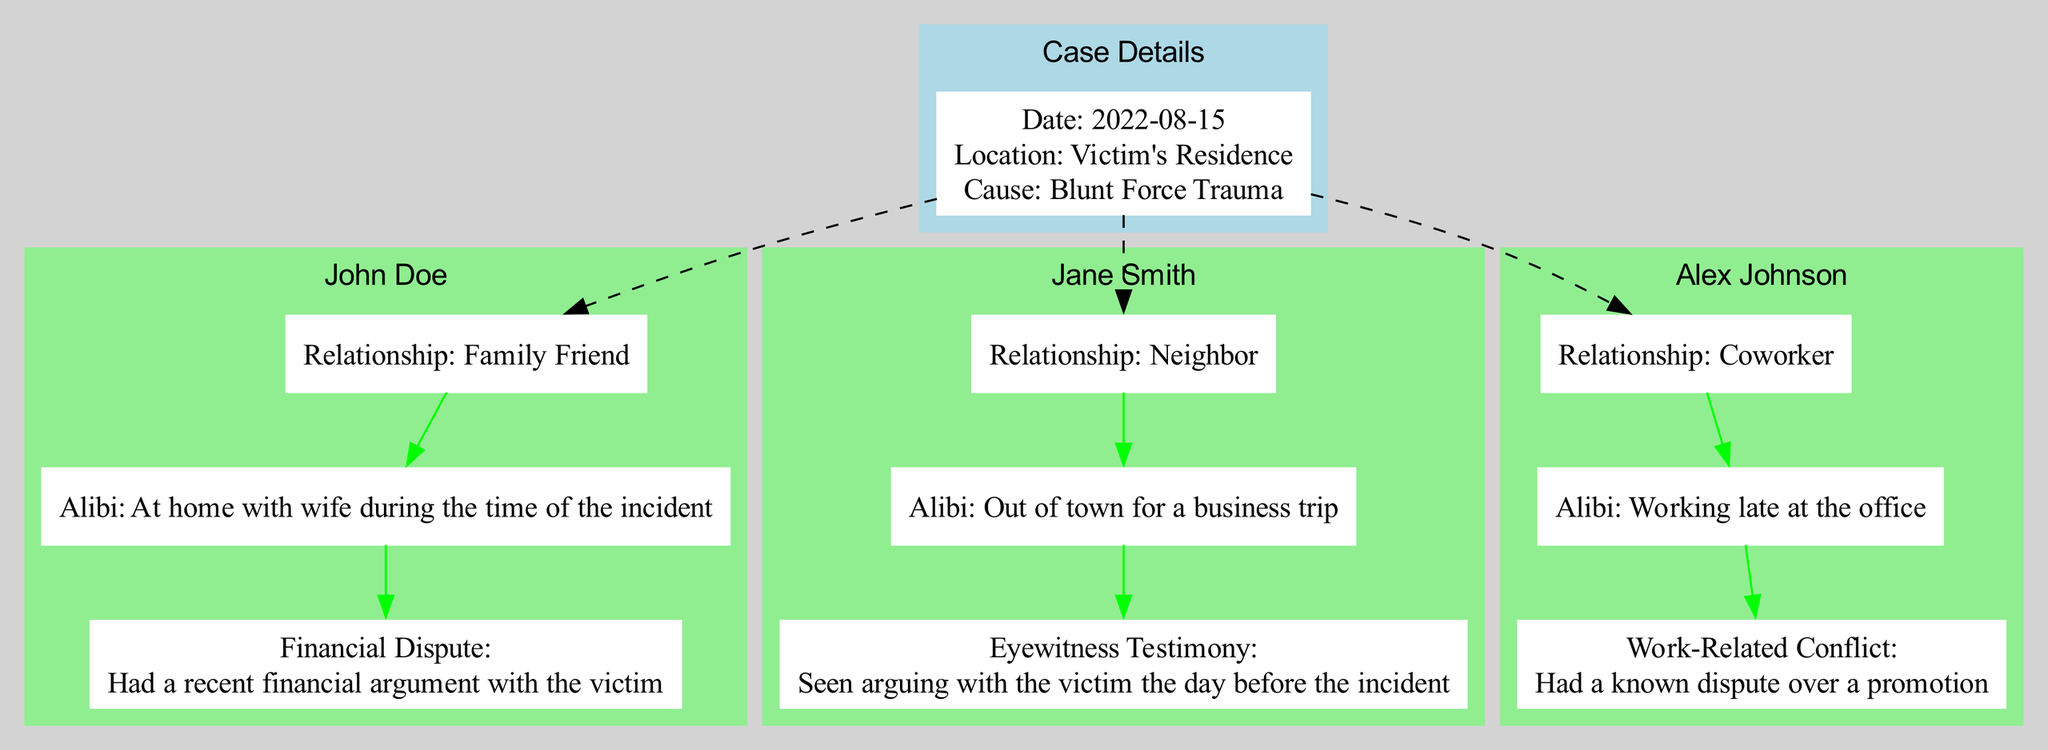What is the name of the first suspect? The diagram lists the potential suspects and shows their names clearly. The first name in the list is John Doe.
Answer: John Doe What was the cause of death? The diagram contains a node detailing the case information, and it specifies the cause of death as blunt force trauma.
Answer: Blunt Force Trauma How many connections does Alex Johnson have to the case? Alex Johnson has one connection listed in the diagram, which is a work-related conflict.
Answer: 1 What was Jane Smith's alibi? The diagram states Jane Smith's alibi as being out of town for a business trip.
Answer: Out of town for a business trip What type of dispute did John Doe have with the victim? The diagram indicates that John Doe had a financial dispute with the victim, detailed in the connections section.
Answer: Financial Dispute Which suspect is a family friend? Upon reviewing the suspects listed in the diagram, the relationship of John Doe is clearly categorized as a family friend.
Answer: John Doe What was Alex Johnson's relationship to the victim? The diagram specifies Alex Johnson's relationship to the victim as a coworker.
Answer: Coworker Which suspect was working late at the office during the incident? By examining the alibis provided in the diagram, Alex Johnson is confirmed to have been working late at the office.
Answer: Alex Johnson What was the nature of the connection between Jane Smith and the victim? The diagram shows that Jane Smith's connection is based on witness testimony of a prior argument with the victim.
Answer: Eyewitness Testimony 